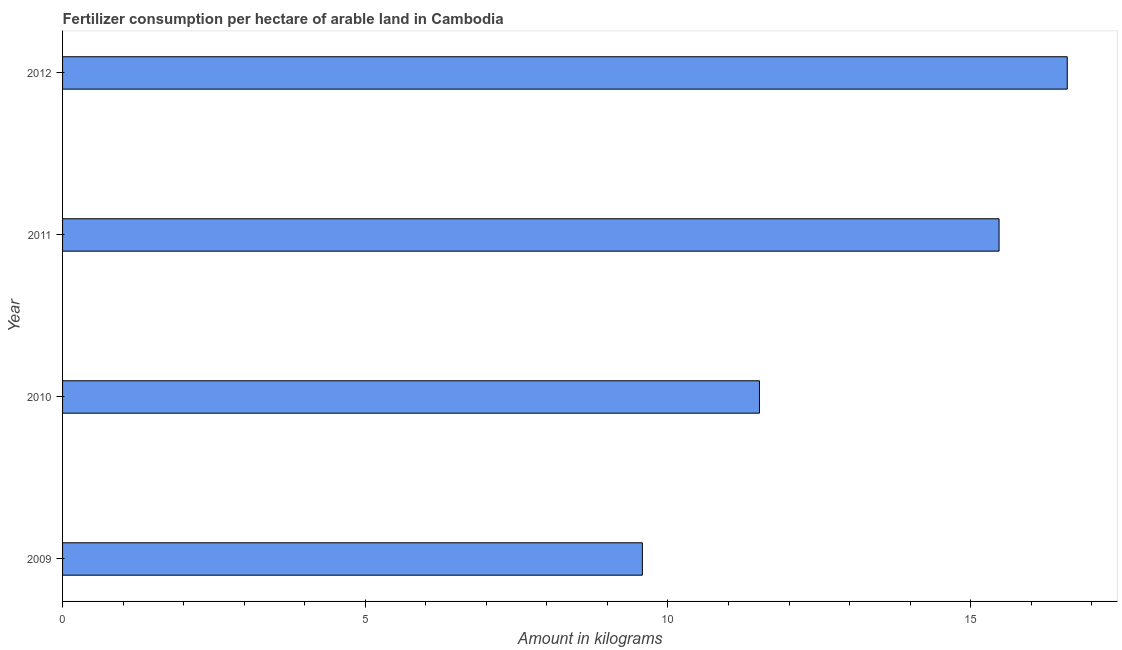Does the graph contain any zero values?
Make the answer very short. No. What is the title of the graph?
Keep it short and to the point. Fertilizer consumption per hectare of arable land in Cambodia . What is the label or title of the X-axis?
Your answer should be very brief. Amount in kilograms. What is the label or title of the Y-axis?
Make the answer very short. Year. What is the amount of fertilizer consumption in 2011?
Your response must be concise. 15.47. Across all years, what is the maximum amount of fertilizer consumption?
Your answer should be very brief. 16.6. Across all years, what is the minimum amount of fertilizer consumption?
Your response must be concise. 9.58. What is the sum of the amount of fertilizer consumption?
Make the answer very short. 53.16. What is the difference between the amount of fertilizer consumption in 2011 and 2012?
Your answer should be compact. -1.13. What is the average amount of fertilizer consumption per year?
Keep it short and to the point. 13.29. What is the median amount of fertilizer consumption?
Your response must be concise. 13.49. In how many years, is the amount of fertilizer consumption greater than 8 kg?
Provide a short and direct response. 4. What is the ratio of the amount of fertilizer consumption in 2009 to that in 2010?
Offer a very short reply. 0.83. Is the amount of fertilizer consumption in 2010 less than that in 2012?
Your answer should be compact. Yes. Is the difference between the amount of fertilizer consumption in 2009 and 2011 greater than the difference between any two years?
Offer a very short reply. No. What is the difference between the highest and the second highest amount of fertilizer consumption?
Provide a short and direct response. 1.13. What is the difference between the highest and the lowest amount of fertilizer consumption?
Keep it short and to the point. 7.02. Are all the bars in the graph horizontal?
Offer a very short reply. Yes. Are the values on the major ticks of X-axis written in scientific E-notation?
Keep it short and to the point. No. What is the Amount in kilograms in 2009?
Give a very brief answer. 9.58. What is the Amount in kilograms in 2010?
Provide a short and direct response. 11.51. What is the Amount in kilograms of 2011?
Your answer should be compact. 15.47. What is the Amount in kilograms in 2012?
Offer a terse response. 16.6. What is the difference between the Amount in kilograms in 2009 and 2010?
Ensure brevity in your answer.  -1.93. What is the difference between the Amount in kilograms in 2009 and 2011?
Keep it short and to the point. -5.89. What is the difference between the Amount in kilograms in 2009 and 2012?
Provide a short and direct response. -7.02. What is the difference between the Amount in kilograms in 2010 and 2011?
Make the answer very short. -3.96. What is the difference between the Amount in kilograms in 2010 and 2012?
Your answer should be very brief. -5.08. What is the difference between the Amount in kilograms in 2011 and 2012?
Your response must be concise. -1.13. What is the ratio of the Amount in kilograms in 2009 to that in 2010?
Your response must be concise. 0.83. What is the ratio of the Amount in kilograms in 2009 to that in 2011?
Provide a short and direct response. 0.62. What is the ratio of the Amount in kilograms in 2009 to that in 2012?
Your response must be concise. 0.58. What is the ratio of the Amount in kilograms in 2010 to that in 2011?
Make the answer very short. 0.74. What is the ratio of the Amount in kilograms in 2010 to that in 2012?
Offer a very short reply. 0.69. What is the ratio of the Amount in kilograms in 2011 to that in 2012?
Keep it short and to the point. 0.93. 